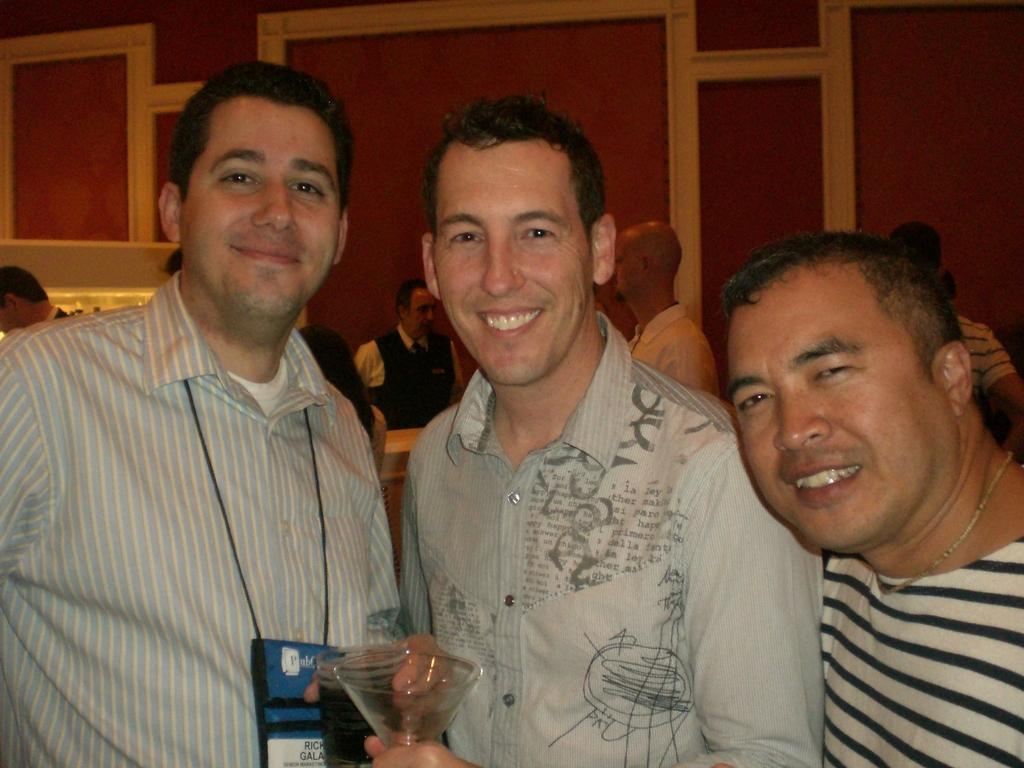How many people are in the image? There are three men in the image. What is the facial expression of the men in the image? All three men are smiling. Can you describe any distinguishing features of one of the men? One of the men is wearing a tag around his neck. What type of sticks are the men using to play in the image? There are no sticks present in the image, and the men are not playing with any. 